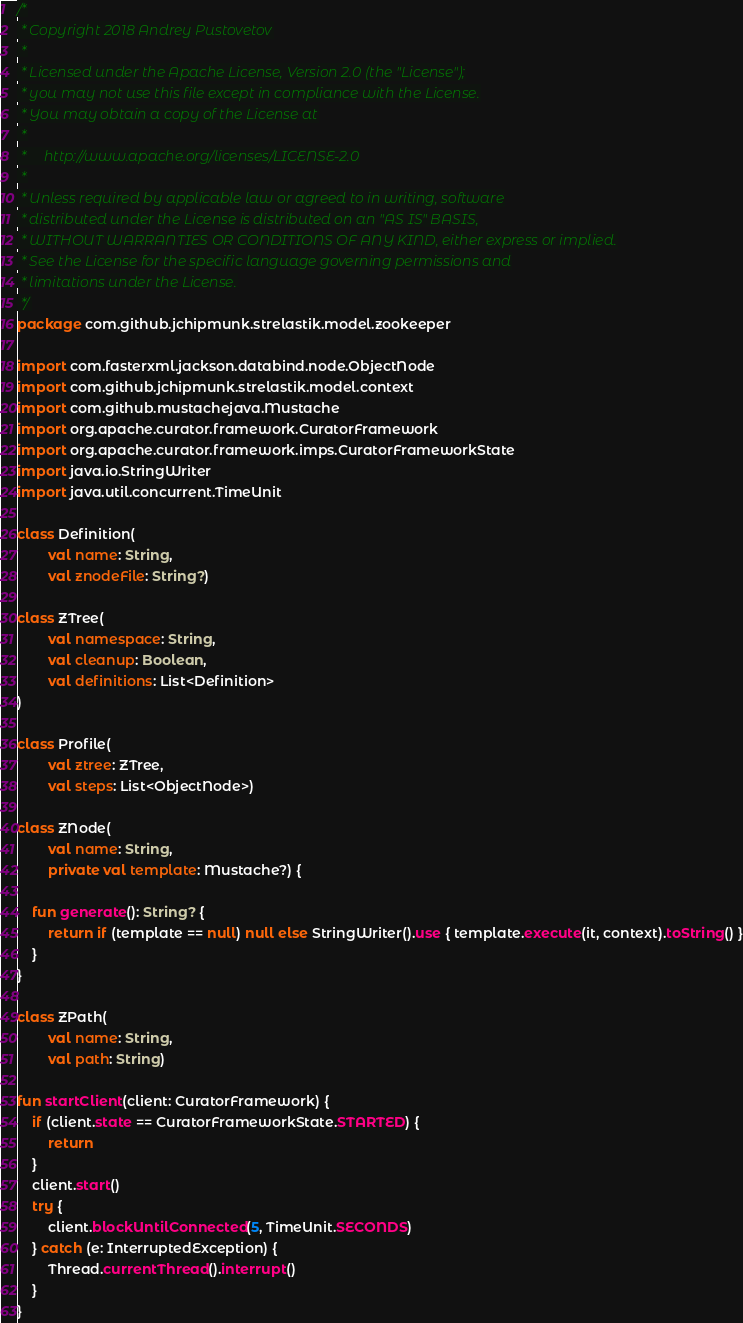Convert code to text. <code><loc_0><loc_0><loc_500><loc_500><_Kotlin_>/*
 * Copyright 2018 Andrey Pustovetov
 *
 * Licensed under the Apache License, Version 2.0 (the "License");
 * you may not use this file except in compliance with the License.
 * You may obtain a copy of the License at
 *
 *     http://www.apache.org/licenses/LICENSE-2.0
 *
 * Unless required by applicable law or agreed to in writing, software
 * distributed under the License is distributed on an "AS IS" BASIS,
 * WITHOUT WARRANTIES OR CONDITIONS OF ANY KIND, either express or implied.
 * See the License for the specific language governing permissions and
 * limitations under the License.
 */
package com.github.jchipmunk.strelastik.model.zookeeper

import com.fasterxml.jackson.databind.node.ObjectNode
import com.github.jchipmunk.strelastik.model.context
import com.github.mustachejava.Mustache
import org.apache.curator.framework.CuratorFramework
import org.apache.curator.framework.imps.CuratorFrameworkState
import java.io.StringWriter
import java.util.concurrent.TimeUnit

class Definition(
        val name: String,
        val znodeFile: String?)

class ZTree(
        val namespace: String,
        val cleanup: Boolean,
        val definitions: List<Definition>
)

class Profile(
        val ztree: ZTree,
        val steps: List<ObjectNode>)

class ZNode(
        val name: String,
        private val template: Mustache?) {

    fun generate(): String? {
        return if (template == null) null else StringWriter().use { template.execute(it, context).toString() }
    }
}

class ZPath(
        val name: String,
        val path: String)

fun startClient(client: CuratorFramework) {
    if (client.state == CuratorFrameworkState.STARTED) {
        return
    }
    client.start()
    try {
        client.blockUntilConnected(5, TimeUnit.SECONDS)
    } catch (e: InterruptedException) {
        Thread.currentThread().interrupt()
    }
}</code> 